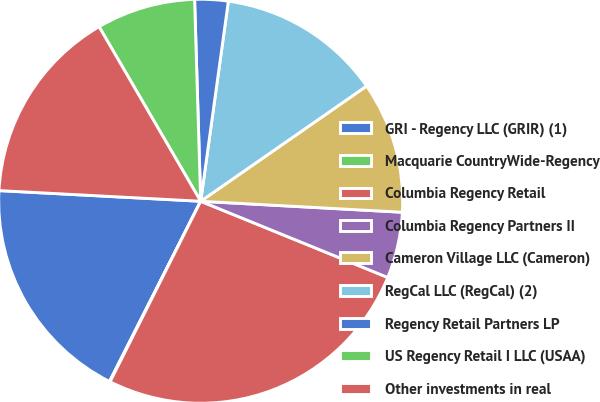Convert chart to OTSL. <chart><loc_0><loc_0><loc_500><loc_500><pie_chart><fcel>GRI - Regency LLC (GRIR) (1)<fcel>Macquarie CountryWide-Regency<fcel>Columbia Regency Retail<fcel>Columbia Regency Partners II<fcel>Cameron Village LLC (Cameron)<fcel>RegCal LLC (RegCal) (2)<fcel>Regency Retail Partners LP<fcel>US Regency Retail I LLC (USAA)<fcel>Other investments in real<nl><fcel>18.39%<fcel>0.05%<fcel>26.25%<fcel>5.29%<fcel>10.53%<fcel>13.15%<fcel>2.67%<fcel>7.91%<fcel>15.77%<nl></chart> 